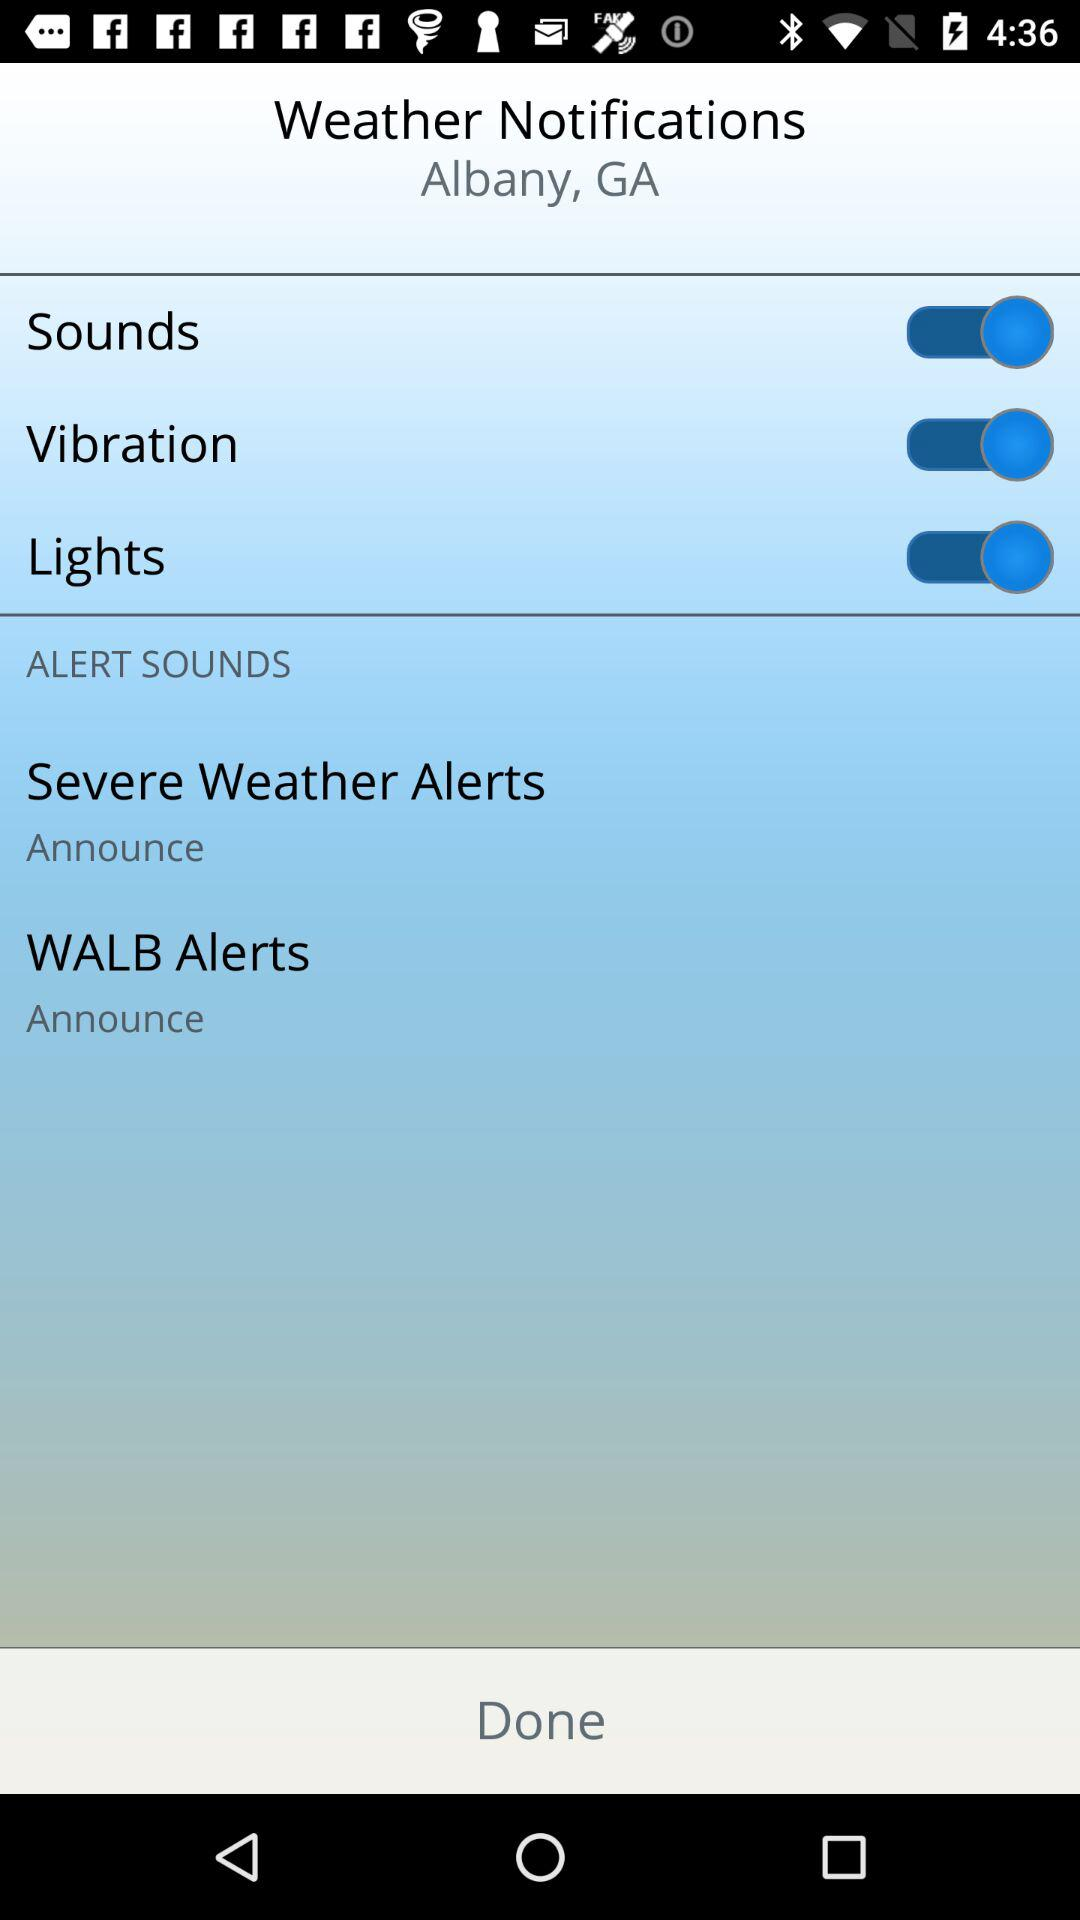When was the last severe weather alert announced?
When the provided information is insufficient, respond with <no answer>. <no answer> 